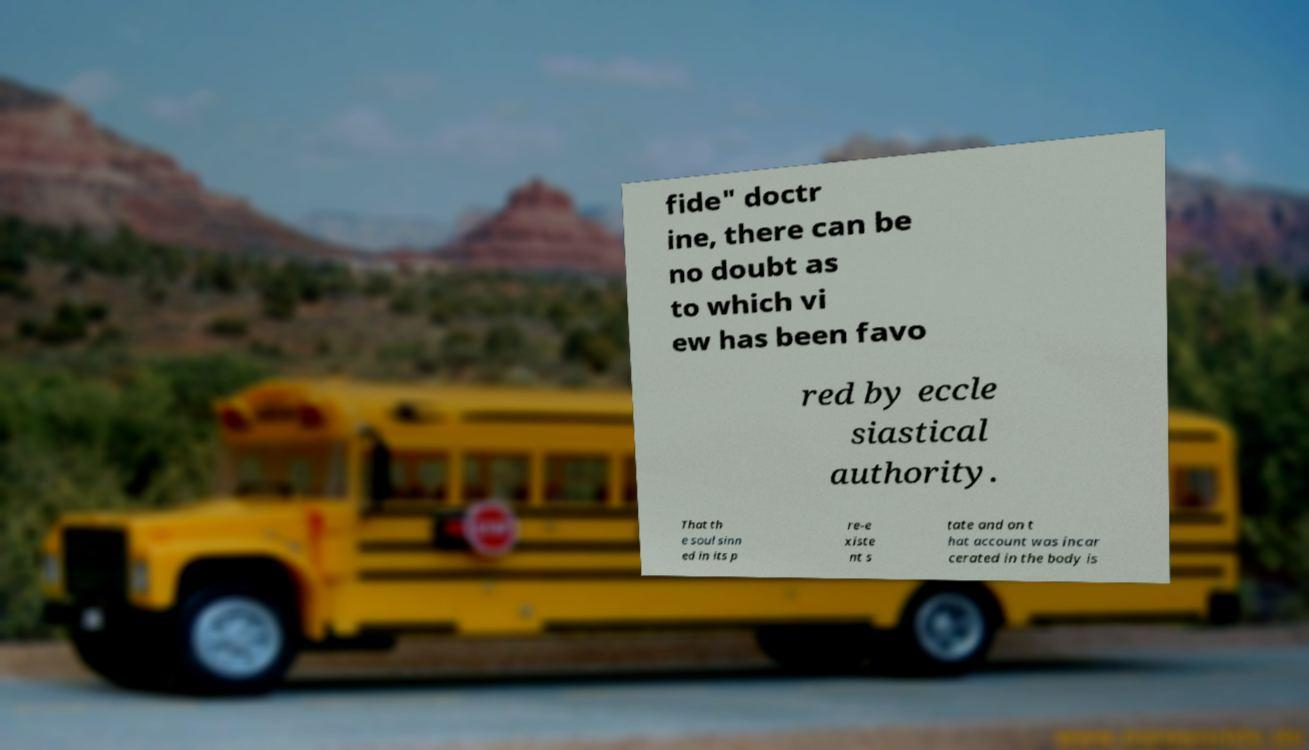What messages or text are displayed in this image? I need them in a readable, typed format. fide" doctr ine, there can be no doubt as to which vi ew has been favo red by eccle siastical authority. That th e soul sinn ed in its p re-e xiste nt s tate and on t hat account was incar cerated in the body is 